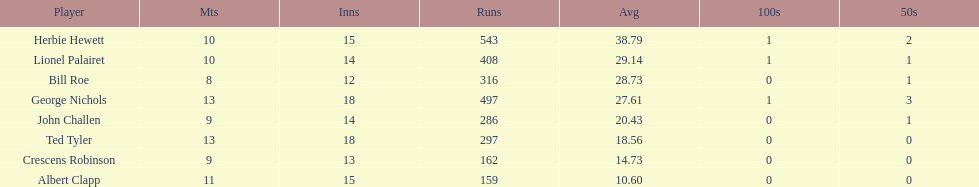How many runs did ted tyler have? 297. 